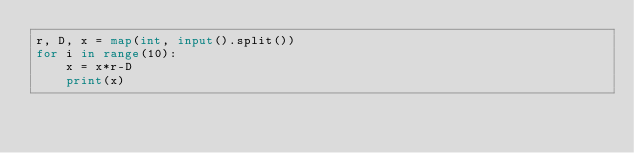<code> <loc_0><loc_0><loc_500><loc_500><_Python_>r, D, x = map(int, input().split())
for i in range(10):
    x = x*r-D
    print(x)</code> 